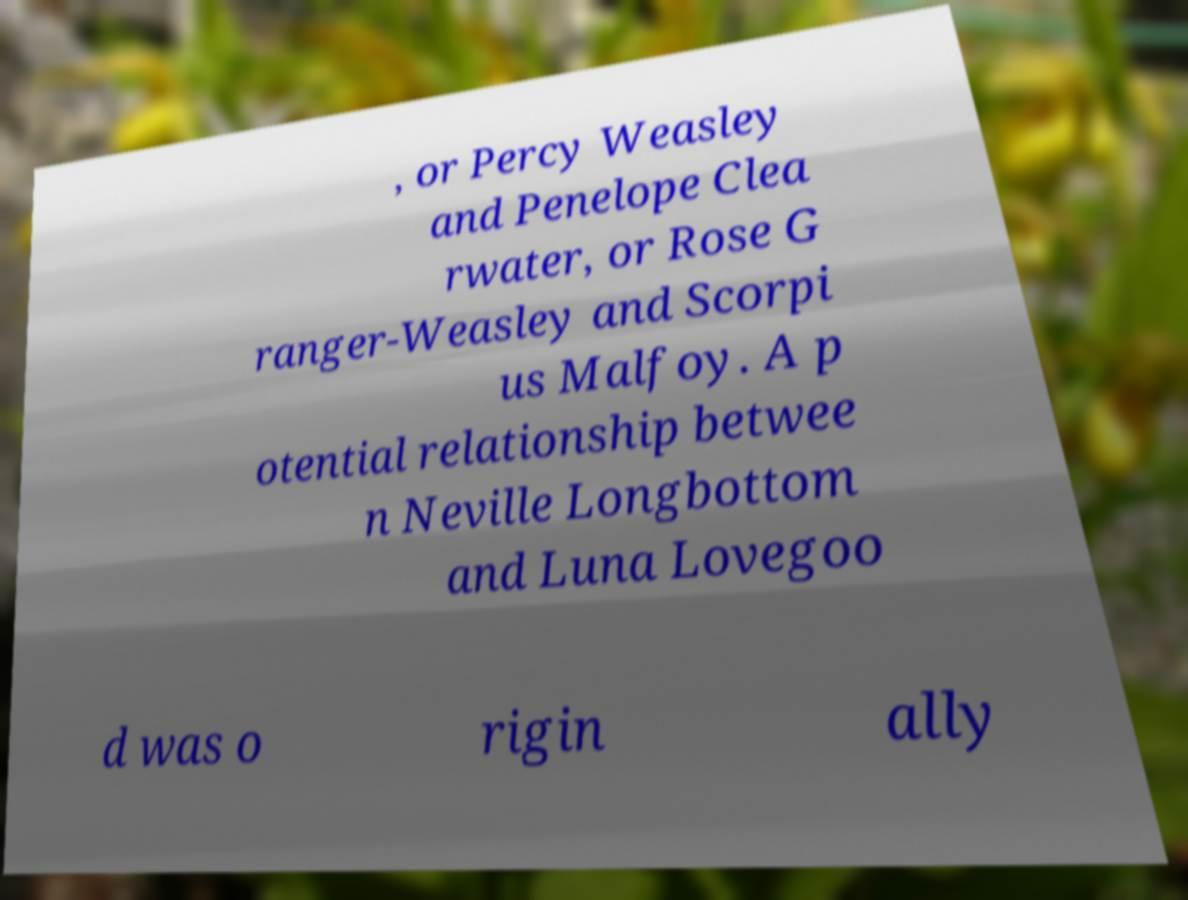What messages or text are displayed in this image? I need them in a readable, typed format. , or Percy Weasley and Penelope Clea rwater, or Rose G ranger-Weasley and Scorpi us Malfoy. A p otential relationship betwee n Neville Longbottom and Luna Lovegoo d was o rigin ally 